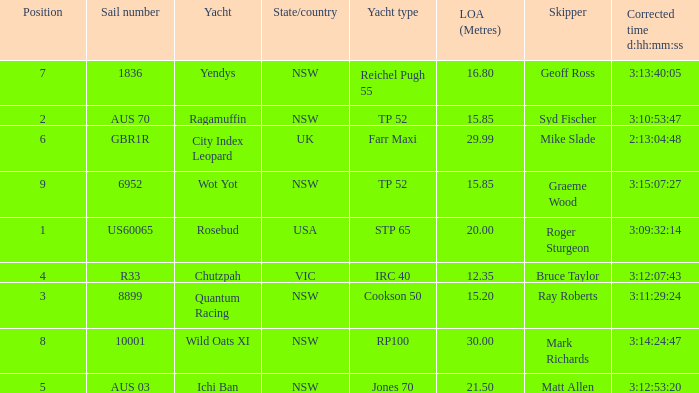What are all sail numbers for the yacht Yendys? 1836.0. 